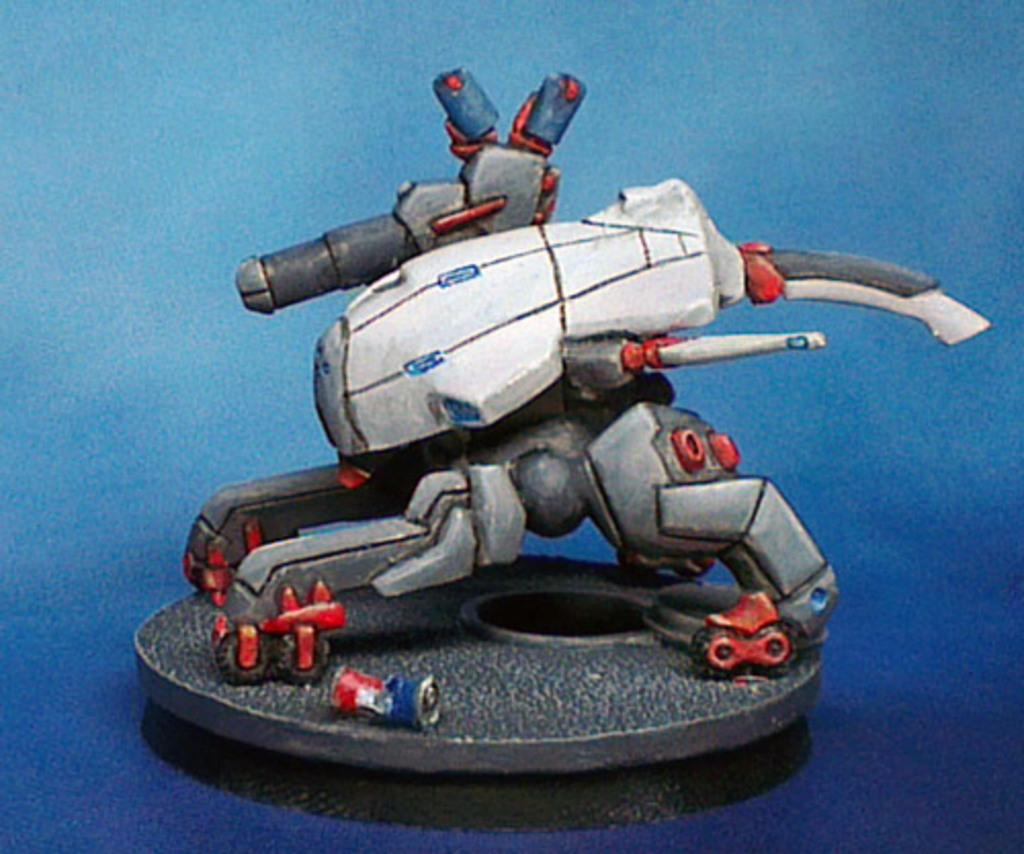What is the main subject of the image? The main subject of the image is an animated picture of a toy. How many women are present in the image? There is no mention of women in the provided fact, so we cannot determine their presence or number in the image. 